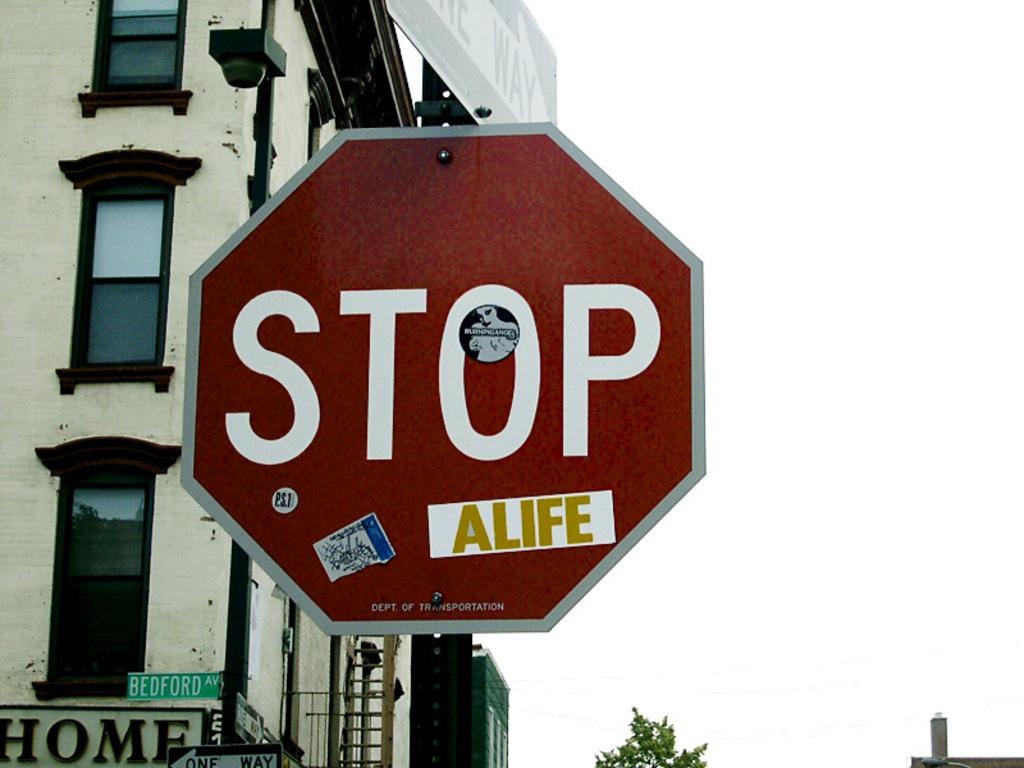What does the sign say?
Your answer should be very brief. Stop. Is this one way?
Your answer should be very brief. Yes. 